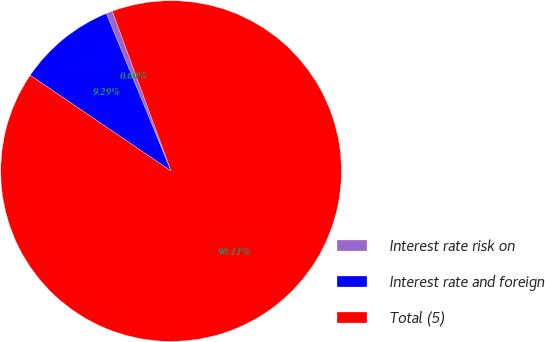<chart> <loc_0><loc_0><loc_500><loc_500><pie_chart><fcel>Interest rate risk on<fcel>Interest rate and foreign<fcel>Total (5)<nl><fcel>0.6%<fcel>9.29%<fcel>90.11%<nl></chart> 